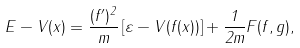<formula> <loc_0><loc_0><loc_500><loc_500>E - V ( x ) = \frac { ( f ^ { \prime } ) ^ { 2 } } { m } \left [ \varepsilon - V ( f ( x ) ) \right ] + \frac { 1 } { 2 m } F ( f , g ) ,</formula> 